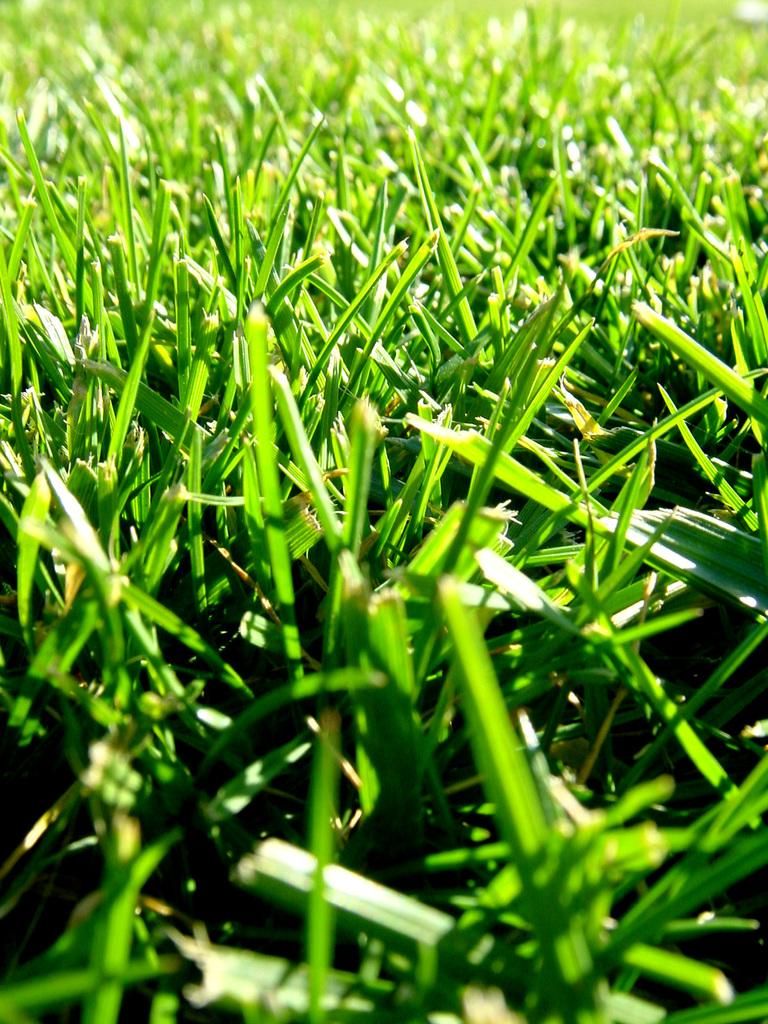What is the primary subject of the image? The primary subject of the image is many plants. Can you describe the plants in the image? Unfortunately, the facts provided do not give specific details about the plants. However, we can confirm that there are multiple plants visible in the image. What type of mine is located near the plants in the image? There is no mine present in the image; it only features many plants. 